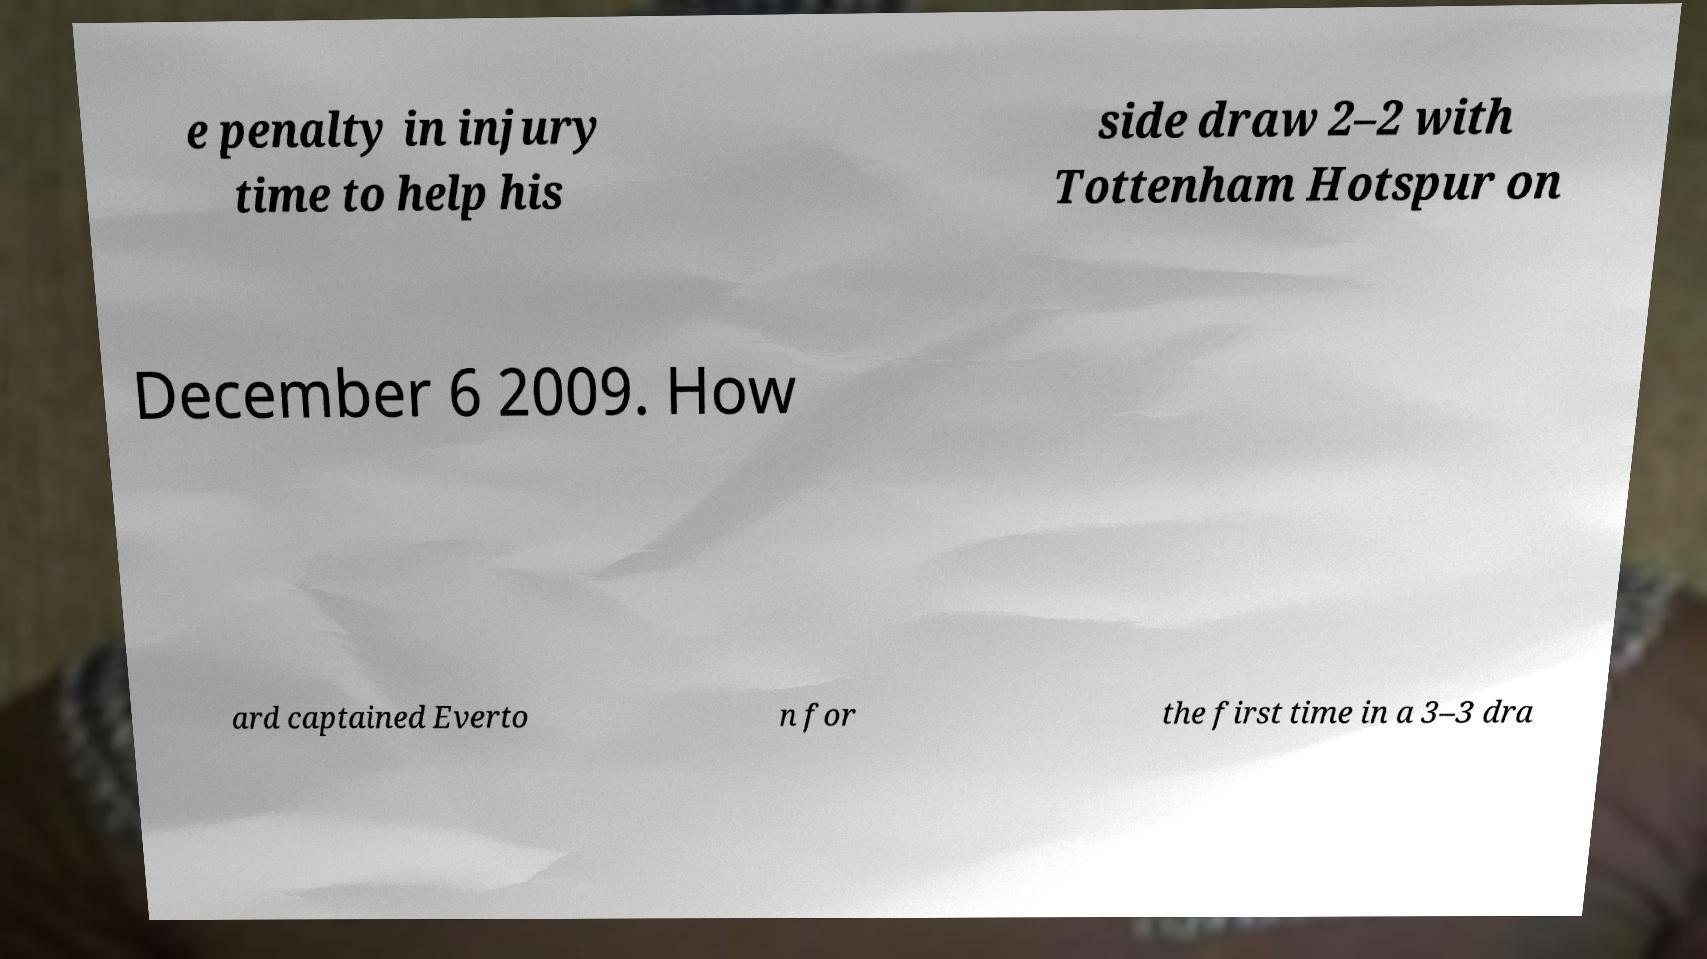Can you accurately transcribe the text from the provided image for me? e penalty in injury time to help his side draw 2–2 with Tottenham Hotspur on December 6 2009. How ard captained Everto n for the first time in a 3–3 dra 